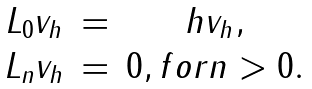<formula> <loc_0><loc_0><loc_500><loc_500>\begin{array} { c c c } L _ { 0 } v _ { h } & = & h v _ { h } , \\ L _ { n } v _ { h } & = & 0 , f o r n > 0 . \end{array}</formula> 